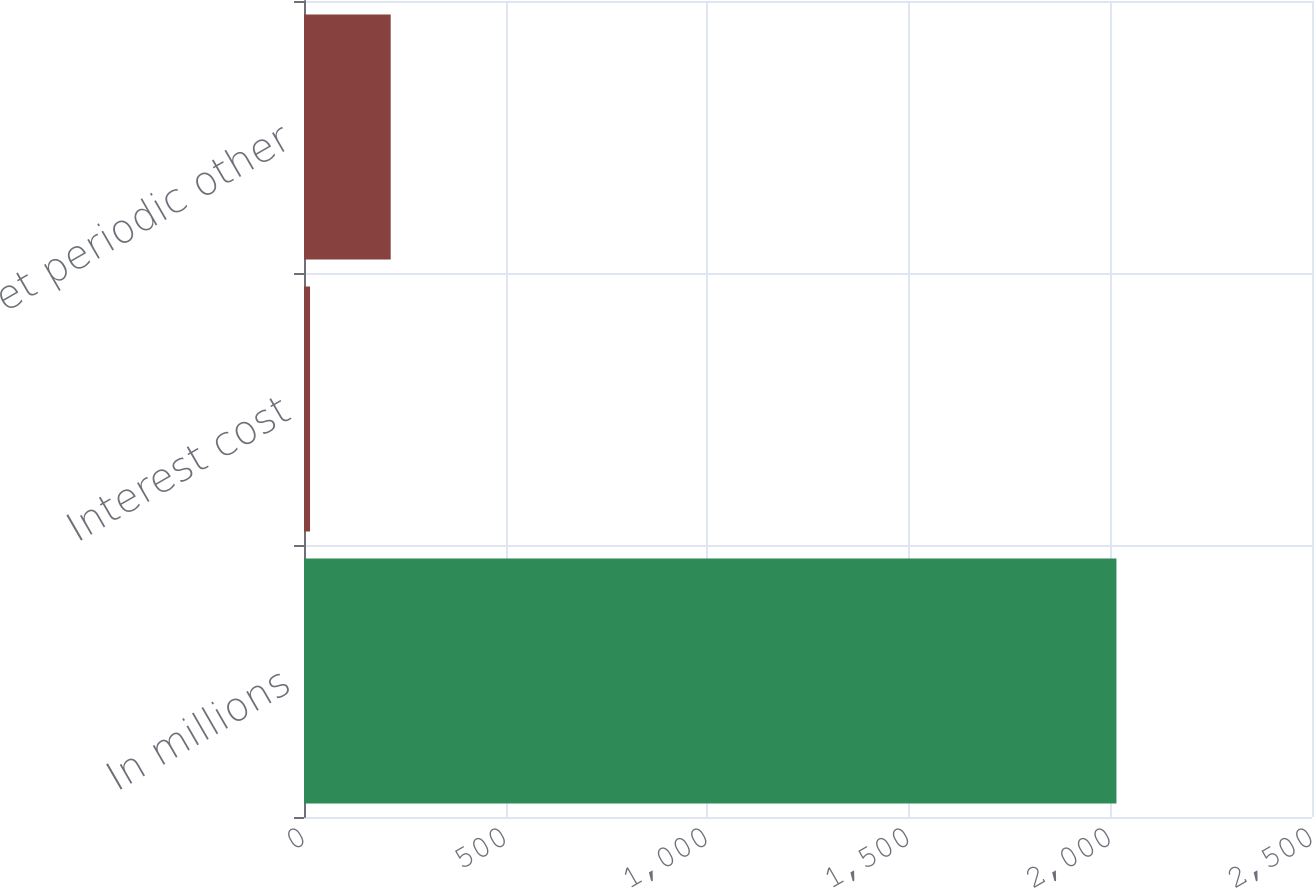<chart> <loc_0><loc_0><loc_500><loc_500><bar_chart><fcel>In millions<fcel>Interest cost<fcel>Net periodic other<nl><fcel>2015<fcel>15<fcel>215<nl></chart> 